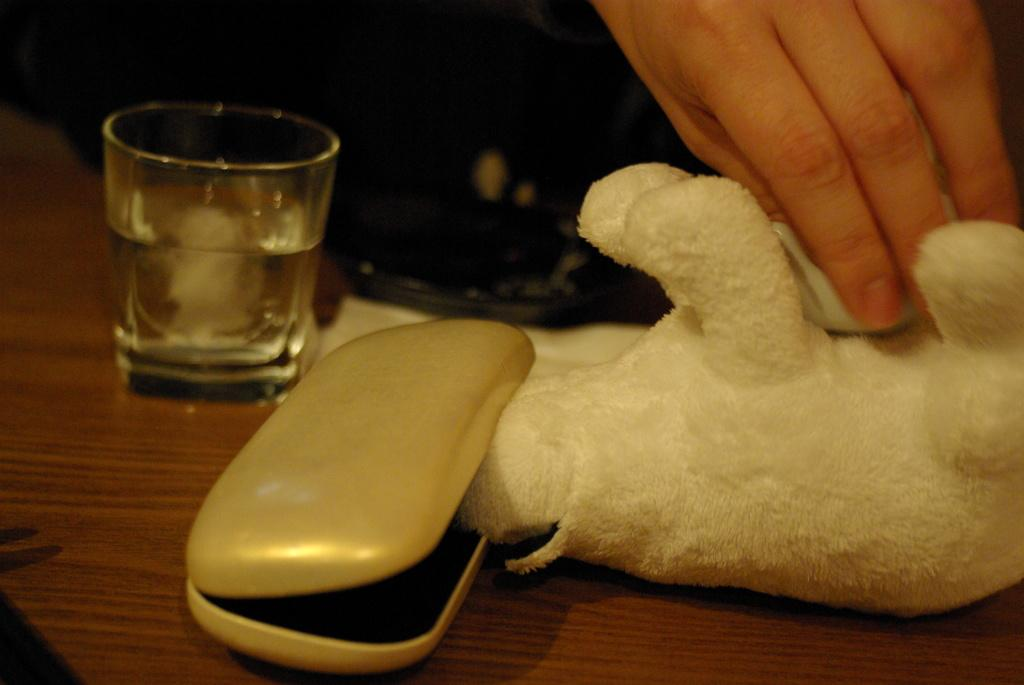What piece of furniture is present in the image? There is a table in the image. Where is the glass located in relation to the table? The glass is on the left side of the table. What object is beside the glass on the table? There is a box beside the glass. What can be seen being held by a hand on the right side of the table? There is a hand holding a doll on the right side of the table. What time is the party scheduled to begin in the image? There is no mention of a party or any specific hour in the image. 